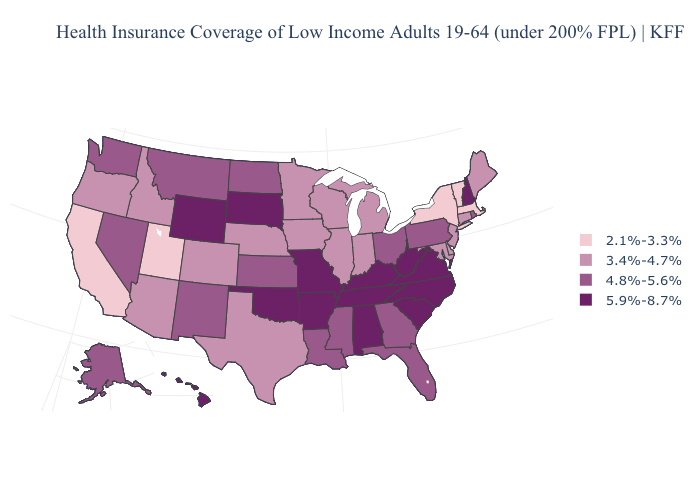Does Tennessee have the lowest value in the USA?
Quick response, please. No. Name the states that have a value in the range 4.8%-5.6%?
Short answer required. Alaska, Florida, Georgia, Kansas, Louisiana, Mississippi, Montana, Nevada, New Mexico, North Dakota, Ohio, Pennsylvania, Rhode Island, Washington. Does Indiana have a higher value than Washington?
Be succinct. No. Which states have the highest value in the USA?
Answer briefly. Alabama, Arkansas, Hawaii, Kentucky, Missouri, New Hampshire, North Carolina, Oklahoma, South Carolina, South Dakota, Tennessee, Virginia, West Virginia, Wyoming. Name the states that have a value in the range 3.4%-4.7%?
Keep it brief. Arizona, Colorado, Connecticut, Delaware, Idaho, Illinois, Indiana, Iowa, Maine, Maryland, Michigan, Minnesota, Nebraska, New Jersey, Oregon, Texas, Wisconsin. Does West Virginia have a lower value than North Carolina?
Answer briefly. No. What is the highest value in the USA?
Quick response, please. 5.9%-8.7%. Name the states that have a value in the range 5.9%-8.7%?
Write a very short answer. Alabama, Arkansas, Hawaii, Kentucky, Missouri, New Hampshire, North Carolina, Oklahoma, South Carolina, South Dakota, Tennessee, Virginia, West Virginia, Wyoming. Name the states that have a value in the range 4.8%-5.6%?
Quick response, please. Alaska, Florida, Georgia, Kansas, Louisiana, Mississippi, Montana, Nevada, New Mexico, North Dakota, Ohio, Pennsylvania, Rhode Island, Washington. Does Nevada have the same value as Michigan?
Short answer required. No. What is the value of Michigan?
Be succinct. 3.4%-4.7%. Among the states that border California , does Nevada have the highest value?
Answer briefly. Yes. What is the value of Iowa?
Quick response, please. 3.4%-4.7%. What is the lowest value in the USA?
Concise answer only. 2.1%-3.3%. Among the states that border Iowa , which have the highest value?
Quick response, please. Missouri, South Dakota. 